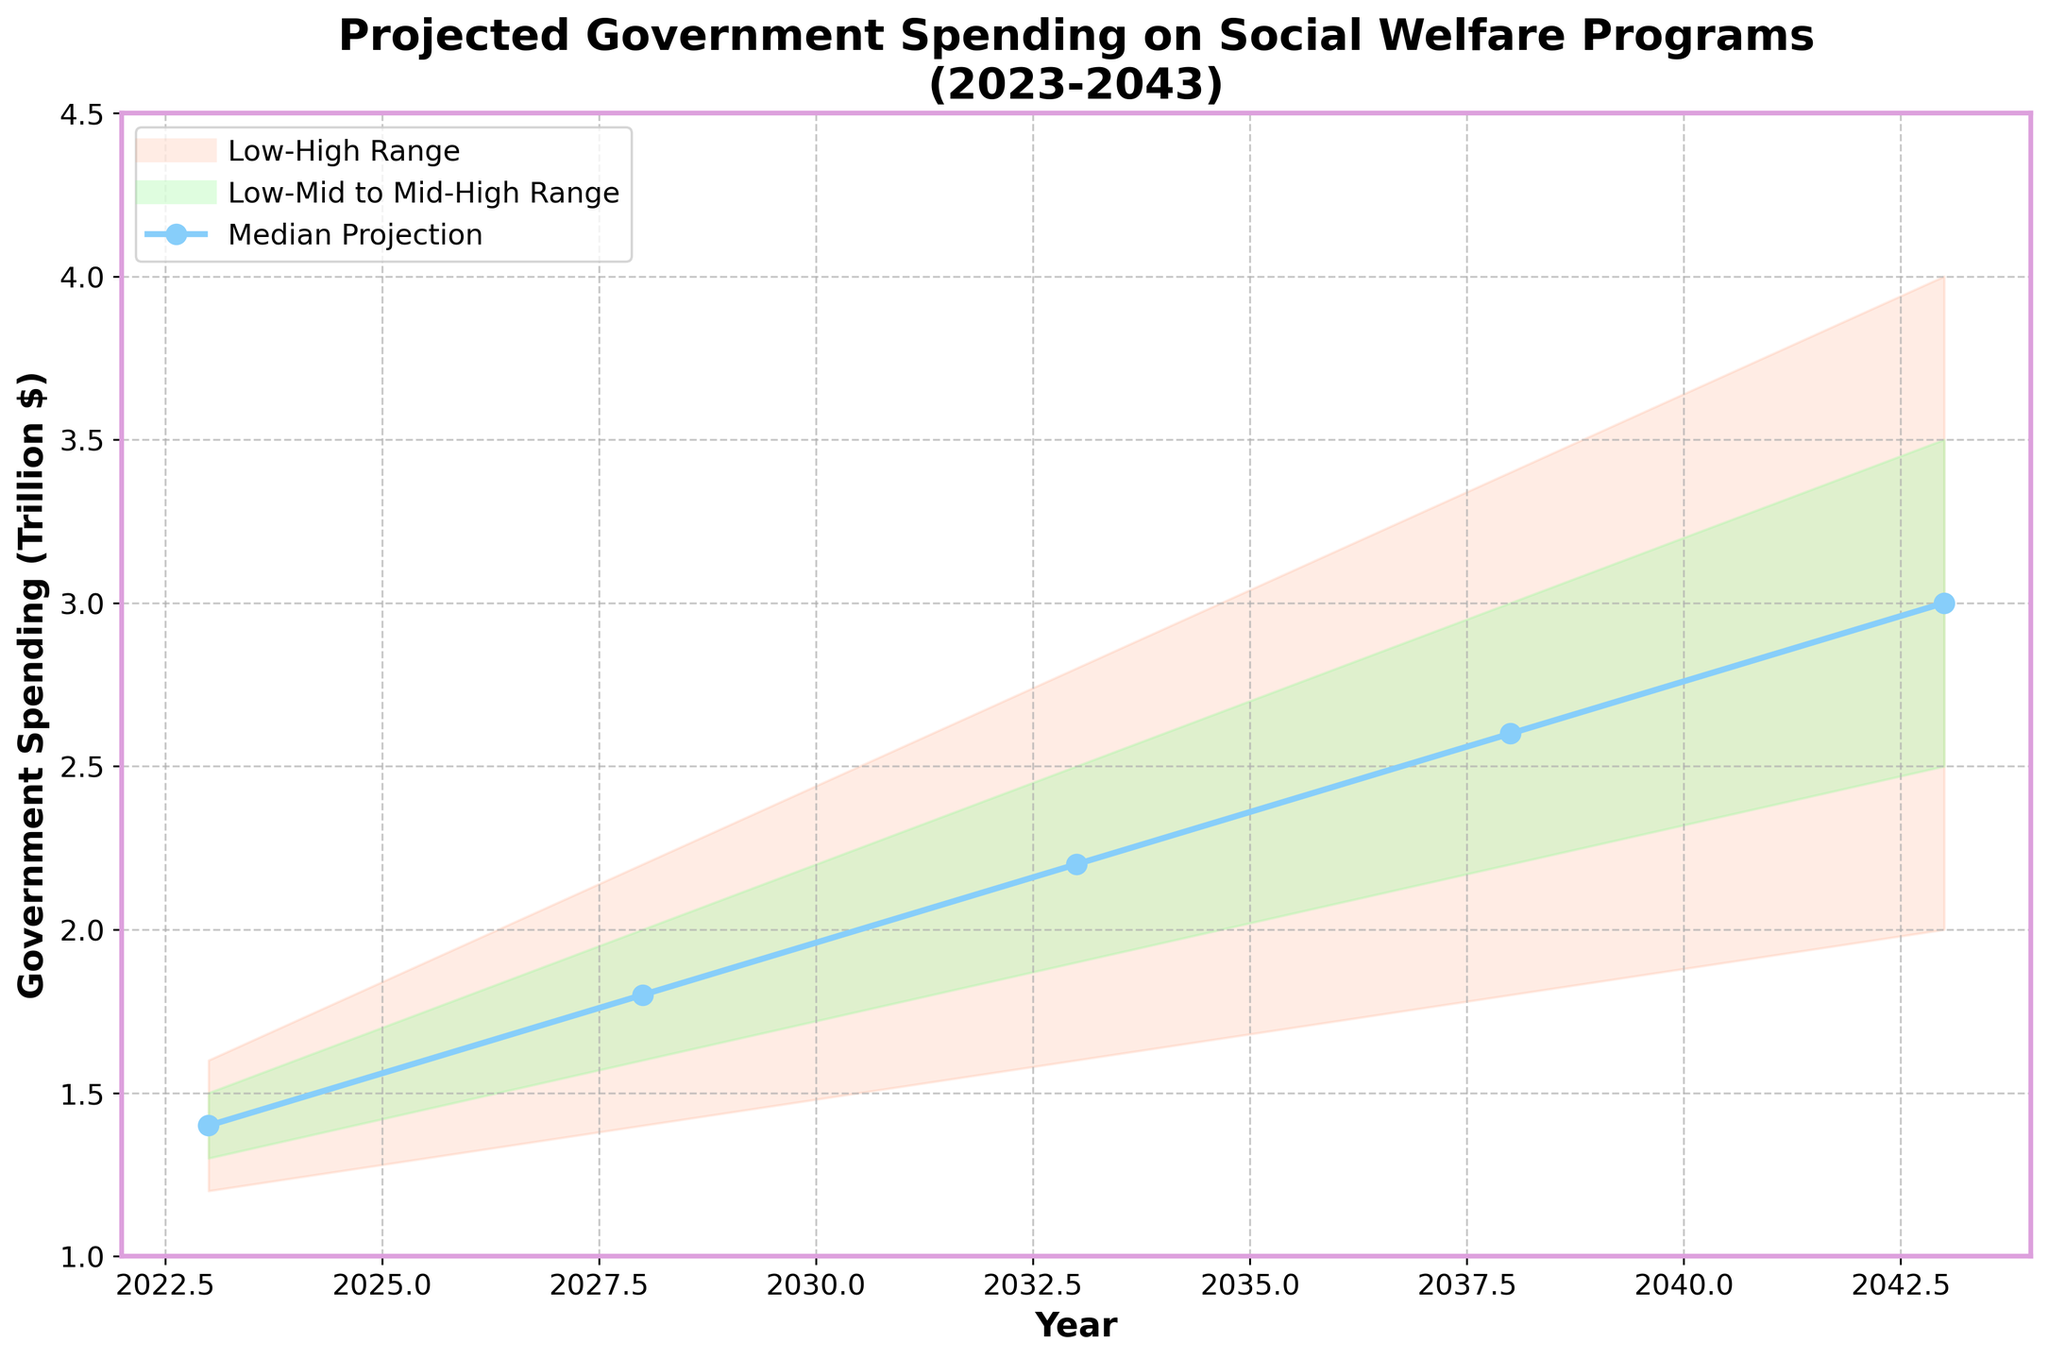What is the title of this chart? The title of the chart is usually found at the top and describes what the chart is about. Here, it is stated clearly.
Answer: Projected Government Spending on Social Welfare Programs (2023-2043) What are the labels of the X and Y axes? The X and Y axis labels are typically found below the X axis and next to the Y axis. Here, they indicate what each axis represents.
Answer: Year (X), Government Spending (Trillion $) (Y) What is the projected median government spending for the year 2033? Look for the "Mid" value in the year 2033 from the data provided.
Answer: 2.2 trillion $ Between which years does the projection start and end? The starting and ending points on the X axis provide this information, indicating the time period of the projection.
Answer: 2023 to 2043 How much does the median projected spending increase from 2023 to 2043? Find the "Mid" values for 2023 and 2043 and calculate the difference between them: 3.0 - 1.4.
Answer: 1.6 trillion $ Which year has the highest high-end projection for government spending? Compare the "High" column values for each year to find the maximum: 2043 with 4.0.
Answer: 2043 What is the range of projected government spending in 2028? Subtract the "Low" value from the "High" value for 2028: 2.2 - 1.4.
Answer: 0.8 trillion $ How does the “Low-Mid to Mid-High” range change from 2023 to 2043? Identify the "Low-Mid" and "Mid-High" values for 2023 and 2043 and then observe how they increase: from 1.3-1.5 to 2.5-3.5.
Answer: Increases from 1.3-1.5 to 2.5-3.5 What is the projected range of government spending in 2038 for the "Low-High" band? Check the values labeled "Low" and "High" for the year 2038 and calculate the difference: 3.4 - 1.8.
Answer: 1.6 trillion $ Is the median projection expected to stay below 3 trillion dollars until 2033? Look at the "Mid" values for each year up to 2033 and check if they are all below 3 trillion dollars.
Answer: Yes What trend can you identify in the mid projections over the years 2023 to 2043? Observe the "Mid" values and note how they increase over time, indicating a rising trend in median projections.
Answer: Increasing 